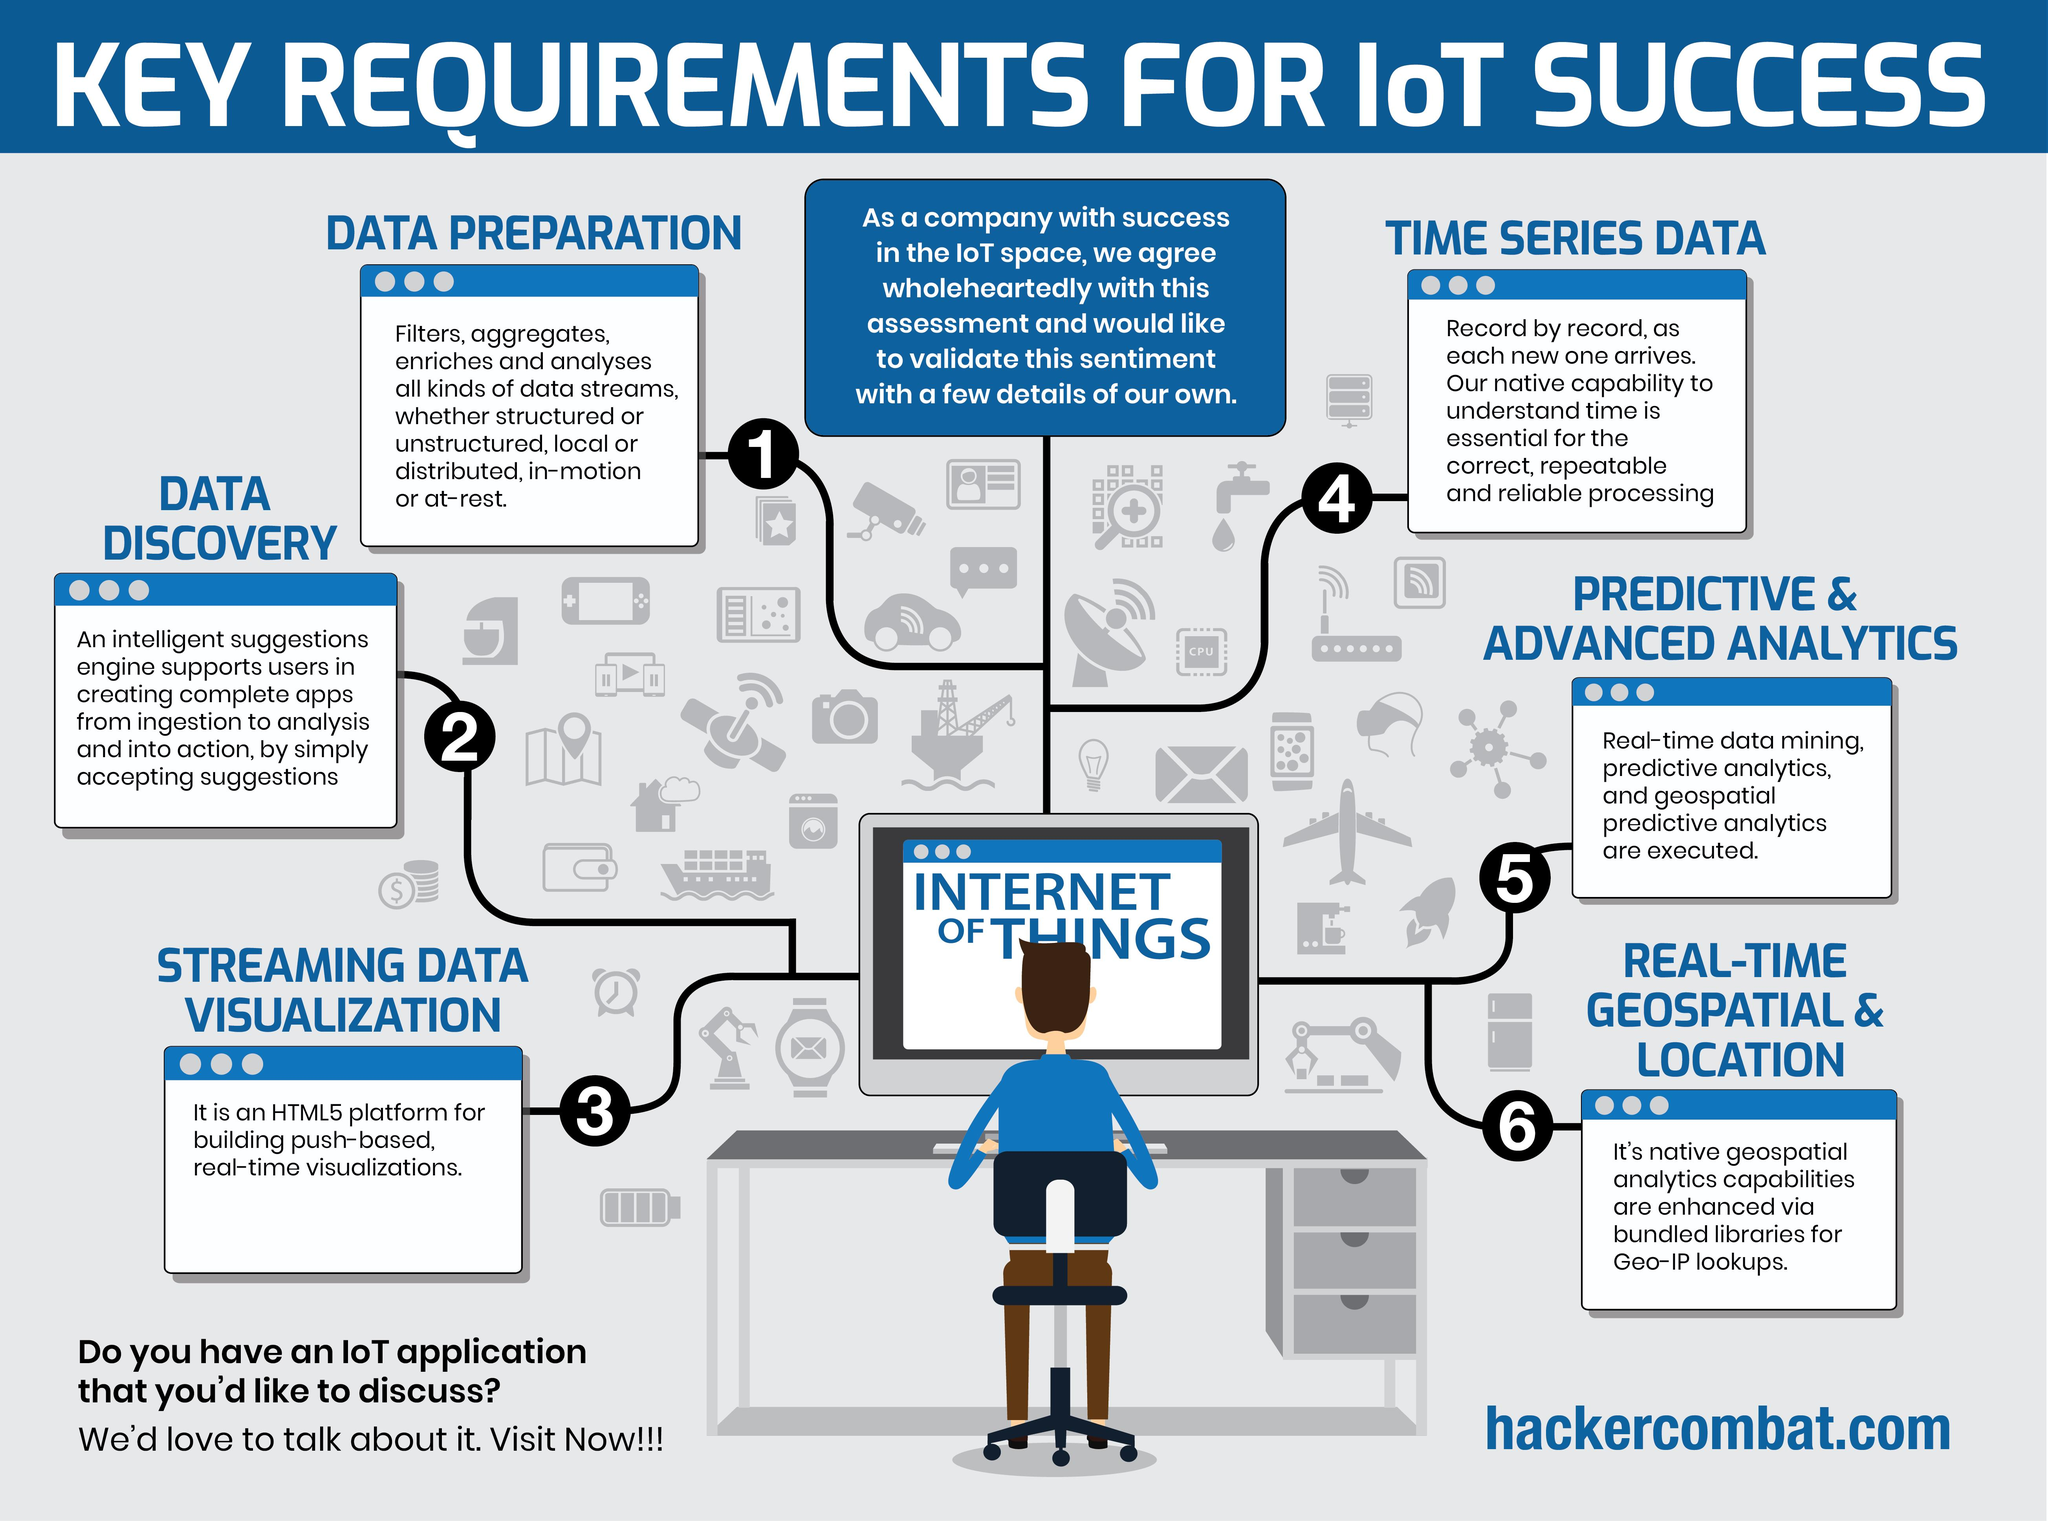Point out several critical features in this image. There are 6 requirements that have been listed as crucial for the success of the Internet of Things (IoT). The infographic does not use blue, grey, or green. Instead, it features green. 